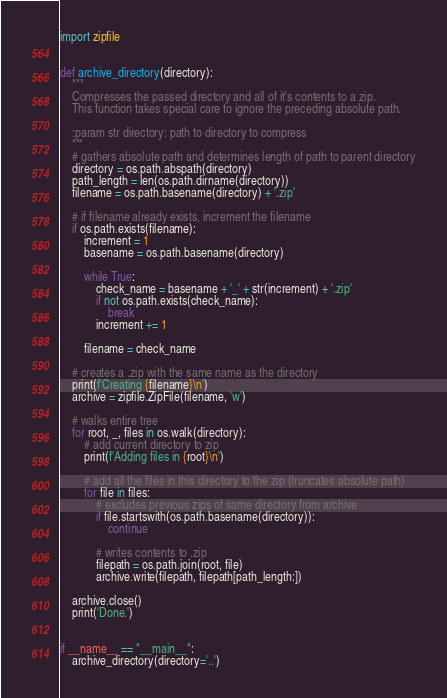Convert code to text. <code><loc_0><loc_0><loc_500><loc_500><_Python_>import zipfile


def archive_directory(directory):
    """
    Compresses the passed directory and all of it's contents to a zip.
    This function takes special care to ignore the preceding absolute path.

    :param str directory: path to directory to compress
    """
    # gathers absolute path and determines length of path to parent directory
    directory = os.path.abspath(directory)
    path_length = len(os.path.dirname(directory))
    filename = os.path.basename(directory) + '.zip'

    # if filename already exists, increment the filename
    if os.path.exists(filename):
        increment = 1
        basename = os.path.basename(directory)

        while True:
            check_name = basename + '_' + str(increment) + '.zip'
            if not os.path.exists(check_name):
                break
            increment += 1

        filename = check_name

    # creates a .zip with the same name as the directory
    print(f'Creating {filename}\n')
    archive = zipfile.ZipFile(filename, 'w')

    # walks entire tree
    for root, _, files in os.walk(directory):
        # add current directory to zip
        print(f'Adding files in {root}\n')

        # add all the files in this directory to the zip (truncates absolute path)
        for file in files:
            # excludes previous zips of same directory from archive
            if file.startswith(os.path.basename(directory)):
                continue

            # writes contents to .zip
            filepath = os.path.join(root, file)
            archive.write(filepath, filepath[path_length:])

    archive.close()
    print('Done.')


if __name__ == "__main__":
    archive_directory(directory='..')
</code> 